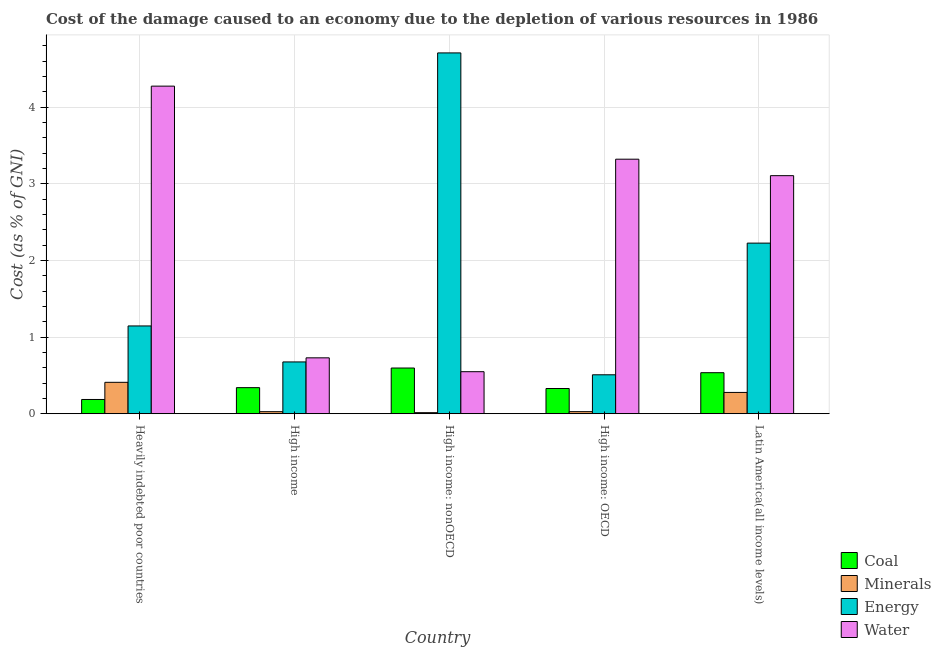How many groups of bars are there?
Offer a terse response. 5. How many bars are there on the 5th tick from the left?
Offer a terse response. 4. How many bars are there on the 1st tick from the right?
Make the answer very short. 4. What is the label of the 3rd group of bars from the left?
Give a very brief answer. High income: nonOECD. What is the cost of damage due to depletion of water in Latin America(all income levels)?
Your response must be concise. 3.1. Across all countries, what is the maximum cost of damage due to depletion of water?
Make the answer very short. 4.27. Across all countries, what is the minimum cost of damage due to depletion of minerals?
Give a very brief answer. 0.01. In which country was the cost of damage due to depletion of minerals maximum?
Offer a very short reply. Heavily indebted poor countries. In which country was the cost of damage due to depletion of energy minimum?
Offer a very short reply. High income: OECD. What is the total cost of damage due to depletion of water in the graph?
Offer a terse response. 11.97. What is the difference between the cost of damage due to depletion of water in Heavily indebted poor countries and that in Latin America(all income levels)?
Make the answer very short. 1.17. What is the difference between the cost of damage due to depletion of energy in High income: OECD and the cost of damage due to depletion of minerals in High income?
Your answer should be compact. 0.48. What is the average cost of damage due to depletion of minerals per country?
Keep it short and to the point. 0.15. What is the difference between the cost of damage due to depletion of minerals and cost of damage due to depletion of energy in Heavily indebted poor countries?
Your answer should be compact. -0.74. What is the ratio of the cost of damage due to depletion of energy in High income to that in Latin America(all income levels)?
Offer a very short reply. 0.3. Is the cost of damage due to depletion of water in High income: OECD less than that in High income: nonOECD?
Provide a succinct answer. No. What is the difference between the highest and the second highest cost of damage due to depletion of energy?
Your answer should be compact. 2.48. What is the difference between the highest and the lowest cost of damage due to depletion of minerals?
Offer a very short reply. 0.4. In how many countries, is the cost of damage due to depletion of minerals greater than the average cost of damage due to depletion of minerals taken over all countries?
Your answer should be compact. 2. Is the sum of the cost of damage due to depletion of energy in High income: nonOECD and Latin America(all income levels) greater than the maximum cost of damage due to depletion of coal across all countries?
Your answer should be very brief. Yes. Is it the case that in every country, the sum of the cost of damage due to depletion of coal and cost of damage due to depletion of water is greater than the sum of cost of damage due to depletion of energy and cost of damage due to depletion of minerals?
Your answer should be very brief. No. What does the 4th bar from the left in High income represents?
Make the answer very short. Water. What does the 1st bar from the right in High income represents?
Your answer should be compact. Water. How many bars are there?
Ensure brevity in your answer.  20. Are the values on the major ticks of Y-axis written in scientific E-notation?
Ensure brevity in your answer.  No. Does the graph contain any zero values?
Keep it short and to the point. No. How many legend labels are there?
Your answer should be compact. 4. What is the title of the graph?
Your answer should be compact. Cost of the damage caused to an economy due to the depletion of various resources in 1986 . What is the label or title of the Y-axis?
Your response must be concise. Cost (as % of GNI). What is the Cost (as % of GNI) in Coal in Heavily indebted poor countries?
Your answer should be compact. 0.19. What is the Cost (as % of GNI) in Minerals in Heavily indebted poor countries?
Offer a terse response. 0.41. What is the Cost (as % of GNI) in Energy in Heavily indebted poor countries?
Provide a succinct answer. 1.14. What is the Cost (as % of GNI) of Water in Heavily indebted poor countries?
Give a very brief answer. 4.27. What is the Cost (as % of GNI) in Coal in High income?
Your answer should be compact. 0.34. What is the Cost (as % of GNI) of Minerals in High income?
Provide a succinct answer. 0.03. What is the Cost (as % of GNI) in Energy in High income?
Provide a succinct answer. 0.68. What is the Cost (as % of GNI) of Water in High income?
Your answer should be very brief. 0.73. What is the Cost (as % of GNI) in Coal in High income: nonOECD?
Offer a very short reply. 0.6. What is the Cost (as % of GNI) of Minerals in High income: nonOECD?
Provide a short and direct response. 0.01. What is the Cost (as % of GNI) in Energy in High income: nonOECD?
Make the answer very short. 4.71. What is the Cost (as % of GNI) of Water in High income: nonOECD?
Give a very brief answer. 0.55. What is the Cost (as % of GNI) of Coal in High income: OECD?
Your answer should be compact. 0.33. What is the Cost (as % of GNI) in Minerals in High income: OECD?
Provide a short and direct response. 0.03. What is the Cost (as % of GNI) of Energy in High income: OECD?
Give a very brief answer. 0.51. What is the Cost (as % of GNI) in Water in High income: OECD?
Provide a short and direct response. 3.32. What is the Cost (as % of GNI) of Coal in Latin America(all income levels)?
Provide a succinct answer. 0.54. What is the Cost (as % of GNI) of Minerals in Latin America(all income levels)?
Give a very brief answer. 0.28. What is the Cost (as % of GNI) of Energy in Latin America(all income levels)?
Offer a terse response. 2.23. What is the Cost (as % of GNI) in Water in Latin America(all income levels)?
Offer a terse response. 3.1. Across all countries, what is the maximum Cost (as % of GNI) of Coal?
Your answer should be very brief. 0.6. Across all countries, what is the maximum Cost (as % of GNI) in Minerals?
Your response must be concise. 0.41. Across all countries, what is the maximum Cost (as % of GNI) in Energy?
Ensure brevity in your answer.  4.71. Across all countries, what is the maximum Cost (as % of GNI) in Water?
Provide a short and direct response. 4.27. Across all countries, what is the minimum Cost (as % of GNI) of Coal?
Offer a terse response. 0.19. Across all countries, what is the minimum Cost (as % of GNI) of Minerals?
Provide a short and direct response. 0.01. Across all countries, what is the minimum Cost (as % of GNI) of Energy?
Provide a succinct answer. 0.51. Across all countries, what is the minimum Cost (as % of GNI) of Water?
Provide a succinct answer. 0.55. What is the total Cost (as % of GNI) of Coal in the graph?
Your answer should be compact. 1.99. What is the total Cost (as % of GNI) of Minerals in the graph?
Ensure brevity in your answer.  0.76. What is the total Cost (as % of GNI) in Energy in the graph?
Provide a short and direct response. 9.26. What is the total Cost (as % of GNI) of Water in the graph?
Offer a terse response. 11.97. What is the difference between the Cost (as % of GNI) in Coal in Heavily indebted poor countries and that in High income?
Offer a terse response. -0.15. What is the difference between the Cost (as % of GNI) in Minerals in Heavily indebted poor countries and that in High income?
Offer a terse response. 0.38. What is the difference between the Cost (as % of GNI) of Energy in Heavily indebted poor countries and that in High income?
Offer a very short reply. 0.47. What is the difference between the Cost (as % of GNI) in Water in Heavily indebted poor countries and that in High income?
Your response must be concise. 3.54. What is the difference between the Cost (as % of GNI) in Coal in Heavily indebted poor countries and that in High income: nonOECD?
Provide a succinct answer. -0.41. What is the difference between the Cost (as % of GNI) in Minerals in Heavily indebted poor countries and that in High income: nonOECD?
Your answer should be very brief. 0.4. What is the difference between the Cost (as % of GNI) of Energy in Heavily indebted poor countries and that in High income: nonOECD?
Keep it short and to the point. -3.56. What is the difference between the Cost (as % of GNI) in Water in Heavily indebted poor countries and that in High income: nonOECD?
Give a very brief answer. 3.72. What is the difference between the Cost (as % of GNI) of Coal in Heavily indebted poor countries and that in High income: OECD?
Keep it short and to the point. -0.14. What is the difference between the Cost (as % of GNI) in Minerals in Heavily indebted poor countries and that in High income: OECD?
Provide a succinct answer. 0.38. What is the difference between the Cost (as % of GNI) in Energy in Heavily indebted poor countries and that in High income: OECD?
Keep it short and to the point. 0.64. What is the difference between the Cost (as % of GNI) of Water in Heavily indebted poor countries and that in High income: OECD?
Offer a very short reply. 0.95. What is the difference between the Cost (as % of GNI) in Coal in Heavily indebted poor countries and that in Latin America(all income levels)?
Provide a short and direct response. -0.35. What is the difference between the Cost (as % of GNI) of Minerals in Heavily indebted poor countries and that in Latin America(all income levels)?
Give a very brief answer. 0.13. What is the difference between the Cost (as % of GNI) of Energy in Heavily indebted poor countries and that in Latin America(all income levels)?
Offer a terse response. -1.08. What is the difference between the Cost (as % of GNI) of Water in Heavily indebted poor countries and that in Latin America(all income levels)?
Make the answer very short. 1.17. What is the difference between the Cost (as % of GNI) in Coal in High income and that in High income: nonOECD?
Offer a terse response. -0.26. What is the difference between the Cost (as % of GNI) in Minerals in High income and that in High income: nonOECD?
Ensure brevity in your answer.  0.01. What is the difference between the Cost (as % of GNI) in Energy in High income and that in High income: nonOECD?
Your response must be concise. -4.03. What is the difference between the Cost (as % of GNI) of Water in High income and that in High income: nonOECD?
Your answer should be very brief. 0.18. What is the difference between the Cost (as % of GNI) in Coal in High income and that in High income: OECD?
Your answer should be very brief. 0.01. What is the difference between the Cost (as % of GNI) in Minerals in High income and that in High income: OECD?
Your response must be concise. -0. What is the difference between the Cost (as % of GNI) of Energy in High income and that in High income: OECD?
Your answer should be compact. 0.17. What is the difference between the Cost (as % of GNI) in Water in High income and that in High income: OECD?
Offer a very short reply. -2.59. What is the difference between the Cost (as % of GNI) of Coal in High income and that in Latin America(all income levels)?
Offer a very short reply. -0.19. What is the difference between the Cost (as % of GNI) in Minerals in High income and that in Latin America(all income levels)?
Offer a very short reply. -0.25. What is the difference between the Cost (as % of GNI) of Energy in High income and that in Latin America(all income levels)?
Ensure brevity in your answer.  -1.55. What is the difference between the Cost (as % of GNI) of Water in High income and that in Latin America(all income levels)?
Make the answer very short. -2.38. What is the difference between the Cost (as % of GNI) in Coal in High income: nonOECD and that in High income: OECD?
Make the answer very short. 0.27. What is the difference between the Cost (as % of GNI) in Minerals in High income: nonOECD and that in High income: OECD?
Keep it short and to the point. -0.01. What is the difference between the Cost (as % of GNI) of Energy in High income: nonOECD and that in High income: OECD?
Keep it short and to the point. 4.2. What is the difference between the Cost (as % of GNI) in Water in High income: nonOECD and that in High income: OECD?
Your response must be concise. -2.77. What is the difference between the Cost (as % of GNI) in Coal in High income: nonOECD and that in Latin America(all income levels)?
Offer a terse response. 0.06. What is the difference between the Cost (as % of GNI) in Minerals in High income: nonOECD and that in Latin America(all income levels)?
Your response must be concise. -0.26. What is the difference between the Cost (as % of GNI) of Energy in High income: nonOECD and that in Latin America(all income levels)?
Keep it short and to the point. 2.48. What is the difference between the Cost (as % of GNI) in Water in High income: nonOECD and that in Latin America(all income levels)?
Your answer should be compact. -2.56. What is the difference between the Cost (as % of GNI) of Coal in High income: OECD and that in Latin America(all income levels)?
Make the answer very short. -0.21. What is the difference between the Cost (as % of GNI) in Minerals in High income: OECD and that in Latin America(all income levels)?
Make the answer very short. -0.25. What is the difference between the Cost (as % of GNI) of Energy in High income: OECD and that in Latin America(all income levels)?
Offer a terse response. -1.72. What is the difference between the Cost (as % of GNI) of Water in High income: OECD and that in Latin America(all income levels)?
Offer a terse response. 0.21. What is the difference between the Cost (as % of GNI) in Coal in Heavily indebted poor countries and the Cost (as % of GNI) in Minerals in High income?
Offer a terse response. 0.16. What is the difference between the Cost (as % of GNI) in Coal in Heavily indebted poor countries and the Cost (as % of GNI) in Energy in High income?
Offer a terse response. -0.49. What is the difference between the Cost (as % of GNI) in Coal in Heavily indebted poor countries and the Cost (as % of GNI) in Water in High income?
Your answer should be very brief. -0.54. What is the difference between the Cost (as % of GNI) in Minerals in Heavily indebted poor countries and the Cost (as % of GNI) in Energy in High income?
Keep it short and to the point. -0.27. What is the difference between the Cost (as % of GNI) of Minerals in Heavily indebted poor countries and the Cost (as % of GNI) of Water in High income?
Give a very brief answer. -0.32. What is the difference between the Cost (as % of GNI) in Energy in Heavily indebted poor countries and the Cost (as % of GNI) in Water in High income?
Offer a terse response. 0.42. What is the difference between the Cost (as % of GNI) of Coal in Heavily indebted poor countries and the Cost (as % of GNI) of Minerals in High income: nonOECD?
Make the answer very short. 0.17. What is the difference between the Cost (as % of GNI) in Coal in Heavily indebted poor countries and the Cost (as % of GNI) in Energy in High income: nonOECD?
Provide a short and direct response. -4.52. What is the difference between the Cost (as % of GNI) in Coal in Heavily indebted poor countries and the Cost (as % of GNI) in Water in High income: nonOECD?
Provide a short and direct response. -0.36. What is the difference between the Cost (as % of GNI) in Minerals in Heavily indebted poor countries and the Cost (as % of GNI) in Energy in High income: nonOECD?
Your response must be concise. -4.3. What is the difference between the Cost (as % of GNI) of Minerals in Heavily indebted poor countries and the Cost (as % of GNI) of Water in High income: nonOECD?
Offer a very short reply. -0.14. What is the difference between the Cost (as % of GNI) in Energy in Heavily indebted poor countries and the Cost (as % of GNI) in Water in High income: nonOECD?
Your response must be concise. 0.6. What is the difference between the Cost (as % of GNI) of Coal in Heavily indebted poor countries and the Cost (as % of GNI) of Minerals in High income: OECD?
Give a very brief answer. 0.16. What is the difference between the Cost (as % of GNI) in Coal in Heavily indebted poor countries and the Cost (as % of GNI) in Energy in High income: OECD?
Provide a succinct answer. -0.32. What is the difference between the Cost (as % of GNI) in Coal in Heavily indebted poor countries and the Cost (as % of GNI) in Water in High income: OECD?
Make the answer very short. -3.13. What is the difference between the Cost (as % of GNI) in Minerals in Heavily indebted poor countries and the Cost (as % of GNI) in Energy in High income: OECD?
Your answer should be compact. -0.1. What is the difference between the Cost (as % of GNI) in Minerals in Heavily indebted poor countries and the Cost (as % of GNI) in Water in High income: OECD?
Ensure brevity in your answer.  -2.91. What is the difference between the Cost (as % of GNI) of Energy in Heavily indebted poor countries and the Cost (as % of GNI) of Water in High income: OECD?
Your response must be concise. -2.17. What is the difference between the Cost (as % of GNI) in Coal in Heavily indebted poor countries and the Cost (as % of GNI) in Minerals in Latin America(all income levels)?
Keep it short and to the point. -0.09. What is the difference between the Cost (as % of GNI) in Coal in Heavily indebted poor countries and the Cost (as % of GNI) in Energy in Latin America(all income levels)?
Offer a terse response. -2.04. What is the difference between the Cost (as % of GNI) of Coal in Heavily indebted poor countries and the Cost (as % of GNI) of Water in Latin America(all income levels)?
Provide a succinct answer. -2.92. What is the difference between the Cost (as % of GNI) in Minerals in Heavily indebted poor countries and the Cost (as % of GNI) in Energy in Latin America(all income levels)?
Make the answer very short. -1.82. What is the difference between the Cost (as % of GNI) of Minerals in Heavily indebted poor countries and the Cost (as % of GNI) of Water in Latin America(all income levels)?
Make the answer very short. -2.69. What is the difference between the Cost (as % of GNI) in Energy in Heavily indebted poor countries and the Cost (as % of GNI) in Water in Latin America(all income levels)?
Make the answer very short. -1.96. What is the difference between the Cost (as % of GNI) in Coal in High income and the Cost (as % of GNI) in Minerals in High income: nonOECD?
Offer a very short reply. 0.33. What is the difference between the Cost (as % of GNI) of Coal in High income and the Cost (as % of GNI) of Energy in High income: nonOECD?
Provide a short and direct response. -4.37. What is the difference between the Cost (as % of GNI) in Coal in High income and the Cost (as % of GNI) in Water in High income: nonOECD?
Give a very brief answer. -0.21. What is the difference between the Cost (as % of GNI) of Minerals in High income and the Cost (as % of GNI) of Energy in High income: nonOECD?
Your response must be concise. -4.68. What is the difference between the Cost (as % of GNI) in Minerals in High income and the Cost (as % of GNI) in Water in High income: nonOECD?
Offer a terse response. -0.52. What is the difference between the Cost (as % of GNI) in Energy in High income and the Cost (as % of GNI) in Water in High income: nonOECD?
Your answer should be very brief. 0.13. What is the difference between the Cost (as % of GNI) of Coal in High income and the Cost (as % of GNI) of Minerals in High income: OECD?
Offer a terse response. 0.31. What is the difference between the Cost (as % of GNI) of Coal in High income and the Cost (as % of GNI) of Energy in High income: OECD?
Give a very brief answer. -0.17. What is the difference between the Cost (as % of GNI) of Coal in High income and the Cost (as % of GNI) of Water in High income: OECD?
Ensure brevity in your answer.  -2.98. What is the difference between the Cost (as % of GNI) of Minerals in High income and the Cost (as % of GNI) of Energy in High income: OECD?
Make the answer very short. -0.48. What is the difference between the Cost (as % of GNI) of Minerals in High income and the Cost (as % of GNI) of Water in High income: OECD?
Provide a succinct answer. -3.29. What is the difference between the Cost (as % of GNI) in Energy in High income and the Cost (as % of GNI) in Water in High income: OECD?
Provide a succinct answer. -2.64. What is the difference between the Cost (as % of GNI) in Coal in High income and the Cost (as % of GNI) in Minerals in Latin America(all income levels)?
Provide a short and direct response. 0.06. What is the difference between the Cost (as % of GNI) of Coal in High income and the Cost (as % of GNI) of Energy in Latin America(all income levels)?
Offer a terse response. -1.88. What is the difference between the Cost (as % of GNI) in Coal in High income and the Cost (as % of GNI) in Water in Latin America(all income levels)?
Provide a short and direct response. -2.76. What is the difference between the Cost (as % of GNI) of Minerals in High income and the Cost (as % of GNI) of Energy in Latin America(all income levels)?
Give a very brief answer. -2.2. What is the difference between the Cost (as % of GNI) in Minerals in High income and the Cost (as % of GNI) in Water in Latin America(all income levels)?
Make the answer very short. -3.08. What is the difference between the Cost (as % of GNI) in Energy in High income and the Cost (as % of GNI) in Water in Latin America(all income levels)?
Your answer should be very brief. -2.43. What is the difference between the Cost (as % of GNI) of Coal in High income: nonOECD and the Cost (as % of GNI) of Minerals in High income: OECD?
Your response must be concise. 0.57. What is the difference between the Cost (as % of GNI) in Coal in High income: nonOECD and the Cost (as % of GNI) in Energy in High income: OECD?
Your answer should be compact. 0.09. What is the difference between the Cost (as % of GNI) of Coal in High income: nonOECD and the Cost (as % of GNI) of Water in High income: OECD?
Offer a very short reply. -2.72. What is the difference between the Cost (as % of GNI) in Minerals in High income: nonOECD and the Cost (as % of GNI) in Energy in High income: OECD?
Provide a short and direct response. -0.49. What is the difference between the Cost (as % of GNI) in Minerals in High income: nonOECD and the Cost (as % of GNI) in Water in High income: OECD?
Ensure brevity in your answer.  -3.31. What is the difference between the Cost (as % of GNI) of Energy in High income: nonOECD and the Cost (as % of GNI) of Water in High income: OECD?
Provide a succinct answer. 1.39. What is the difference between the Cost (as % of GNI) of Coal in High income: nonOECD and the Cost (as % of GNI) of Minerals in Latin America(all income levels)?
Keep it short and to the point. 0.32. What is the difference between the Cost (as % of GNI) of Coal in High income: nonOECD and the Cost (as % of GNI) of Energy in Latin America(all income levels)?
Provide a short and direct response. -1.63. What is the difference between the Cost (as % of GNI) of Coal in High income: nonOECD and the Cost (as % of GNI) of Water in Latin America(all income levels)?
Provide a short and direct response. -2.51. What is the difference between the Cost (as % of GNI) of Minerals in High income: nonOECD and the Cost (as % of GNI) of Energy in Latin America(all income levels)?
Your answer should be compact. -2.21. What is the difference between the Cost (as % of GNI) in Minerals in High income: nonOECD and the Cost (as % of GNI) in Water in Latin America(all income levels)?
Give a very brief answer. -3.09. What is the difference between the Cost (as % of GNI) of Energy in High income: nonOECD and the Cost (as % of GNI) of Water in Latin America(all income levels)?
Ensure brevity in your answer.  1.6. What is the difference between the Cost (as % of GNI) of Coal in High income: OECD and the Cost (as % of GNI) of Minerals in Latin America(all income levels)?
Your answer should be very brief. 0.05. What is the difference between the Cost (as % of GNI) of Coal in High income: OECD and the Cost (as % of GNI) of Energy in Latin America(all income levels)?
Offer a very short reply. -1.9. What is the difference between the Cost (as % of GNI) in Coal in High income: OECD and the Cost (as % of GNI) in Water in Latin America(all income levels)?
Make the answer very short. -2.78. What is the difference between the Cost (as % of GNI) in Minerals in High income: OECD and the Cost (as % of GNI) in Energy in Latin America(all income levels)?
Provide a short and direct response. -2.2. What is the difference between the Cost (as % of GNI) in Minerals in High income: OECD and the Cost (as % of GNI) in Water in Latin America(all income levels)?
Keep it short and to the point. -3.08. What is the difference between the Cost (as % of GNI) in Energy in High income: OECD and the Cost (as % of GNI) in Water in Latin America(all income levels)?
Your answer should be very brief. -2.6. What is the average Cost (as % of GNI) of Coal per country?
Your answer should be very brief. 0.4. What is the average Cost (as % of GNI) in Minerals per country?
Offer a very short reply. 0.15. What is the average Cost (as % of GNI) in Energy per country?
Give a very brief answer. 1.85. What is the average Cost (as % of GNI) of Water per country?
Provide a succinct answer. 2.39. What is the difference between the Cost (as % of GNI) in Coal and Cost (as % of GNI) in Minerals in Heavily indebted poor countries?
Keep it short and to the point. -0.22. What is the difference between the Cost (as % of GNI) of Coal and Cost (as % of GNI) of Energy in Heavily indebted poor countries?
Ensure brevity in your answer.  -0.96. What is the difference between the Cost (as % of GNI) in Coal and Cost (as % of GNI) in Water in Heavily indebted poor countries?
Ensure brevity in your answer.  -4.09. What is the difference between the Cost (as % of GNI) in Minerals and Cost (as % of GNI) in Energy in Heavily indebted poor countries?
Your answer should be compact. -0.73. What is the difference between the Cost (as % of GNI) in Minerals and Cost (as % of GNI) in Water in Heavily indebted poor countries?
Your answer should be compact. -3.86. What is the difference between the Cost (as % of GNI) of Energy and Cost (as % of GNI) of Water in Heavily indebted poor countries?
Ensure brevity in your answer.  -3.13. What is the difference between the Cost (as % of GNI) in Coal and Cost (as % of GNI) in Minerals in High income?
Provide a succinct answer. 0.31. What is the difference between the Cost (as % of GNI) in Coal and Cost (as % of GNI) in Energy in High income?
Make the answer very short. -0.34. What is the difference between the Cost (as % of GNI) of Coal and Cost (as % of GNI) of Water in High income?
Provide a succinct answer. -0.39. What is the difference between the Cost (as % of GNI) in Minerals and Cost (as % of GNI) in Energy in High income?
Your response must be concise. -0.65. What is the difference between the Cost (as % of GNI) in Minerals and Cost (as % of GNI) in Water in High income?
Ensure brevity in your answer.  -0.7. What is the difference between the Cost (as % of GNI) in Energy and Cost (as % of GNI) in Water in High income?
Keep it short and to the point. -0.05. What is the difference between the Cost (as % of GNI) of Coal and Cost (as % of GNI) of Minerals in High income: nonOECD?
Offer a very short reply. 0.58. What is the difference between the Cost (as % of GNI) in Coal and Cost (as % of GNI) in Energy in High income: nonOECD?
Make the answer very short. -4.11. What is the difference between the Cost (as % of GNI) of Coal and Cost (as % of GNI) of Water in High income: nonOECD?
Provide a succinct answer. 0.05. What is the difference between the Cost (as % of GNI) in Minerals and Cost (as % of GNI) in Energy in High income: nonOECD?
Your answer should be compact. -4.69. What is the difference between the Cost (as % of GNI) in Minerals and Cost (as % of GNI) in Water in High income: nonOECD?
Your answer should be compact. -0.53. What is the difference between the Cost (as % of GNI) in Energy and Cost (as % of GNI) in Water in High income: nonOECD?
Provide a short and direct response. 4.16. What is the difference between the Cost (as % of GNI) in Coal and Cost (as % of GNI) in Minerals in High income: OECD?
Offer a very short reply. 0.3. What is the difference between the Cost (as % of GNI) in Coal and Cost (as % of GNI) in Energy in High income: OECD?
Offer a terse response. -0.18. What is the difference between the Cost (as % of GNI) in Coal and Cost (as % of GNI) in Water in High income: OECD?
Provide a succinct answer. -2.99. What is the difference between the Cost (as % of GNI) of Minerals and Cost (as % of GNI) of Energy in High income: OECD?
Provide a short and direct response. -0.48. What is the difference between the Cost (as % of GNI) in Minerals and Cost (as % of GNI) in Water in High income: OECD?
Your answer should be very brief. -3.29. What is the difference between the Cost (as % of GNI) of Energy and Cost (as % of GNI) of Water in High income: OECD?
Give a very brief answer. -2.81. What is the difference between the Cost (as % of GNI) of Coal and Cost (as % of GNI) of Minerals in Latin America(all income levels)?
Your answer should be very brief. 0.26. What is the difference between the Cost (as % of GNI) of Coal and Cost (as % of GNI) of Energy in Latin America(all income levels)?
Keep it short and to the point. -1.69. What is the difference between the Cost (as % of GNI) in Coal and Cost (as % of GNI) in Water in Latin America(all income levels)?
Your answer should be very brief. -2.57. What is the difference between the Cost (as % of GNI) of Minerals and Cost (as % of GNI) of Energy in Latin America(all income levels)?
Make the answer very short. -1.95. What is the difference between the Cost (as % of GNI) of Minerals and Cost (as % of GNI) of Water in Latin America(all income levels)?
Your response must be concise. -2.83. What is the difference between the Cost (as % of GNI) in Energy and Cost (as % of GNI) in Water in Latin America(all income levels)?
Give a very brief answer. -0.88. What is the ratio of the Cost (as % of GNI) in Coal in Heavily indebted poor countries to that in High income?
Provide a short and direct response. 0.55. What is the ratio of the Cost (as % of GNI) in Minerals in Heavily indebted poor countries to that in High income?
Keep it short and to the point. 15.3. What is the ratio of the Cost (as % of GNI) of Energy in Heavily indebted poor countries to that in High income?
Give a very brief answer. 1.69. What is the ratio of the Cost (as % of GNI) of Water in Heavily indebted poor countries to that in High income?
Offer a terse response. 5.86. What is the ratio of the Cost (as % of GNI) of Coal in Heavily indebted poor countries to that in High income: nonOECD?
Offer a terse response. 0.31. What is the ratio of the Cost (as % of GNI) in Minerals in Heavily indebted poor countries to that in High income: nonOECD?
Keep it short and to the point. 29.35. What is the ratio of the Cost (as % of GNI) in Energy in Heavily indebted poor countries to that in High income: nonOECD?
Provide a succinct answer. 0.24. What is the ratio of the Cost (as % of GNI) of Water in Heavily indebted poor countries to that in High income: nonOECD?
Ensure brevity in your answer.  7.79. What is the ratio of the Cost (as % of GNI) in Coal in Heavily indebted poor countries to that in High income: OECD?
Give a very brief answer. 0.57. What is the ratio of the Cost (as % of GNI) of Minerals in Heavily indebted poor countries to that in High income: OECD?
Offer a very short reply. 15. What is the ratio of the Cost (as % of GNI) in Energy in Heavily indebted poor countries to that in High income: OECD?
Give a very brief answer. 2.25. What is the ratio of the Cost (as % of GNI) of Water in Heavily indebted poor countries to that in High income: OECD?
Your answer should be very brief. 1.29. What is the ratio of the Cost (as % of GNI) of Coal in Heavily indebted poor countries to that in Latin America(all income levels)?
Ensure brevity in your answer.  0.35. What is the ratio of the Cost (as % of GNI) of Minerals in Heavily indebted poor countries to that in Latin America(all income levels)?
Your answer should be compact. 1.47. What is the ratio of the Cost (as % of GNI) in Energy in Heavily indebted poor countries to that in Latin America(all income levels)?
Keep it short and to the point. 0.51. What is the ratio of the Cost (as % of GNI) of Water in Heavily indebted poor countries to that in Latin America(all income levels)?
Ensure brevity in your answer.  1.38. What is the ratio of the Cost (as % of GNI) of Coal in High income to that in High income: nonOECD?
Your answer should be compact. 0.57. What is the ratio of the Cost (as % of GNI) in Minerals in High income to that in High income: nonOECD?
Keep it short and to the point. 1.92. What is the ratio of the Cost (as % of GNI) in Energy in High income to that in High income: nonOECD?
Give a very brief answer. 0.14. What is the ratio of the Cost (as % of GNI) in Water in High income to that in High income: nonOECD?
Your answer should be very brief. 1.33. What is the ratio of the Cost (as % of GNI) of Coal in High income to that in High income: OECD?
Your answer should be compact. 1.03. What is the ratio of the Cost (as % of GNI) in Minerals in High income to that in High income: OECD?
Ensure brevity in your answer.  0.98. What is the ratio of the Cost (as % of GNI) in Energy in High income to that in High income: OECD?
Your answer should be very brief. 1.33. What is the ratio of the Cost (as % of GNI) of Water in High income to that in High income: OECD?
Keep it short and to the point. 0.22. What is the ratio of the Cost (as % of GNI) in Coal in High income to that in Latin America(all income levels)?
Ensure brevity in your answer.  0.64. What is the ratio of the Cost (as % of GNI) in Minerals in High income to that in Latin America(all income levels)?
Your response must be concise. 0.1. What is the ratio of the Cost (as % of GNI) in Energy in High income to that in Latin America(all income levels)?
Offer a very short reply. 0.3. What is the ratio of the Cost (as % of GNI) of Water in High income to that in Latin America(all income levels)?
Keep it short and to the point. 0.23. What is the ratio of the Cost (as % of GNI) of Coal in High income: nonOECD to that in High income: OECD?
Provide a succinct answer. 1.81. What is the ratio of the Cost (as % of GNI) in Minerals in High income: nonOECD to that in High income: OECD?
Your response must be concise. 0.51. What is the ratio of the Cost (as % of GNI) in Energy in High income: nonOECD to that in High income: OECD?
Provide a short and direct response. 9.26. What is the ratio of the Cost (as % of GNI) in Water in High income: nonOECD to that in High income: OECD?
Offer a terse response. 0.17. What is the ratio of the Cost (as % of GNI) in Coal in High income: nonOECD to that in Latin America(all income levels)?
Your answer should be very brief. 1.11. What is the ratio of the Cost (as % of GNI) in Minerals in High income: nonOECD to that in Latin America(all income levels)?
Provide a succinct answer. 0.05. What is the ratio of the Cost (as % of GNI) in Energy in High income: nonOECD to that in Latin America(all income levels)?
Your answer should be very brief. 2.11. What is the ratio of the Cost (as % of GNI) in Water in High income: nonOECD to that in Latin America(all income levels)?
Your answer should be compact. 0.18. What is the ratio of the Cost (as % of GNI) of Coal in High income: OECD to that in Latin America(all income levels)?
Offer a terse response. 0.61. What is the ratio of the Cost (as % of GNI) in Minerals in High income: OECD to that in Latin America(all income levels)?
Offer a very short reply. 0.1. What is the ratio of the Cost (as % of GNI) in Energy in High income: OECD to that in Latin America(all income levels)?
Your answer should be very brief. 0.23. What is the ratio of the Cost (as % of GNI) in Water in High income: OECD to that in Latin America(all income levels)?
Offer a terse response. 1.07. What is the difference between the highest and the second highest Cost (as % of GNI) of Coal?
Offer a terse response. 0.06. What is the difference between the highest and the second highest Cost (as % of GNI) in Minerals?
Your response must be concise. 0.13. What is the difference between the highest and the second highest Cost (as % of GNI) in Energy?
Your response must be concise. 2.48. What is the difference between the highest and the second highest Cost (as % of GNI) of Water?
Provide a short and direct response. 0.95. What is the difference between the highest and the lowest Cost (as % of GNI) in Coal?
Your answer should be very brief. 0.41. What is the difference between the highest and the lowest Cost (as % of GNI) of Minerals?
Give a very brief answer. 0.4. What is the difference between the highest and the lowest Cost (as % of GNI) of Energy?
Offer a very short reply. 4.2. What is the difference between the highest and the lowest Cost (as % of GNI) of Water?
Make the answer very short. 3.72. 